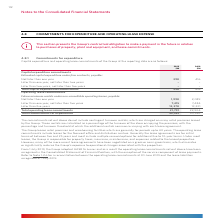According to Woolworths Limited's financial document, What is the unit used in the table? According to the financial document, $M. The relevant text states: "2019 2018 $M $M..." Also, What is the total commitments for expenditure in 2019? According to the financial document, 22,189 (in millions). The relevant text states: "s 21,791 22,904 Total commitments for expenditure 22,189 23,320..." Also, What establishments do the Group lease? The Group leases retail premises and warehousing facilities which are generally for periods up to 40 years.. The document states: "The Group leases retail premises and warehousing facilities which are generally for periods up to 40 years. The operating lease commitments include le..." Also, can you calculate: What is the difference in total operating lease commitments between 2018 and 2019? Based on the calculation: 22,904 - 21,791 , the result is 1113 (in millions). This is based on the information: "s 12,378 13,331 Total operating lease commitments 21,791 22,904 Total commitments for expenditure 22,189 23,320 8 13,331 Total operating lease commitments 21,791 22,904 Total commitments for expenditu..." The key data points involved are: 21,791, 22,904. Also, can you calculate: What is the average total commitments for expenditures for 2018 and 2019? To answer this question, I need to perform calculations using the financial data. The calculation is: (22,189 + 23,320)/2 , which equals 22754.5 (in millions). This is based on the information: "1 22,904 Total commitments for expenditure 22,189 23,320 s 21,791 22,904 Total commitments for expenditure 22,189 23,320..." The key data points involved are: 22,189, 23,320. Also, can you calculate: What is the percentage constitution of total capital expenditure commitments in the total commitments for expenditure in 2018? Based on the calculation: 416/23,320 , the result is 1.78 (percentage). This is based on the information: "1 22,904 Total commitments for expenditure 22,189 23,320 m contracts, payable: Not later than one year 398 416 Later than one year, not later than two years – – Later than two years, not later than fi..." The key data points involved are: 23,320, 416. 